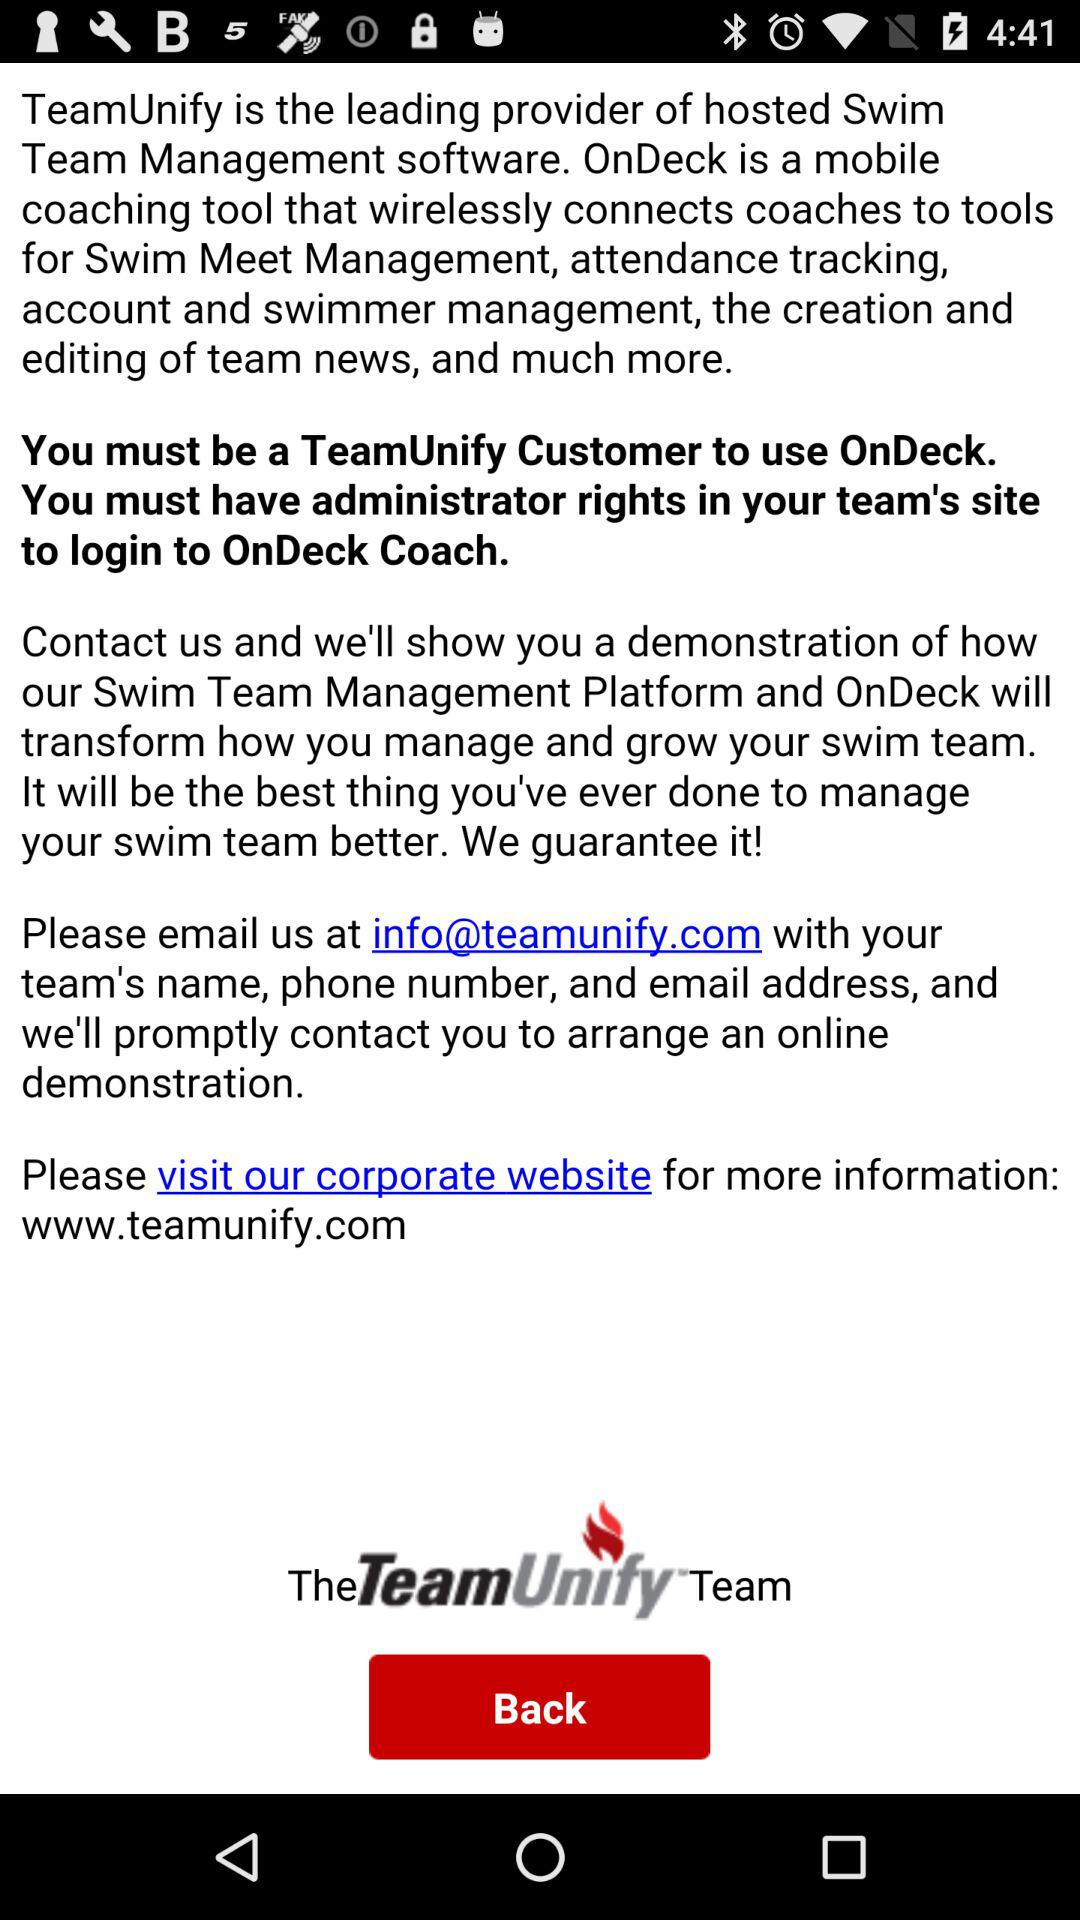Which website should we visit for more information? You should visit the www.teamunify.com website for more information. 